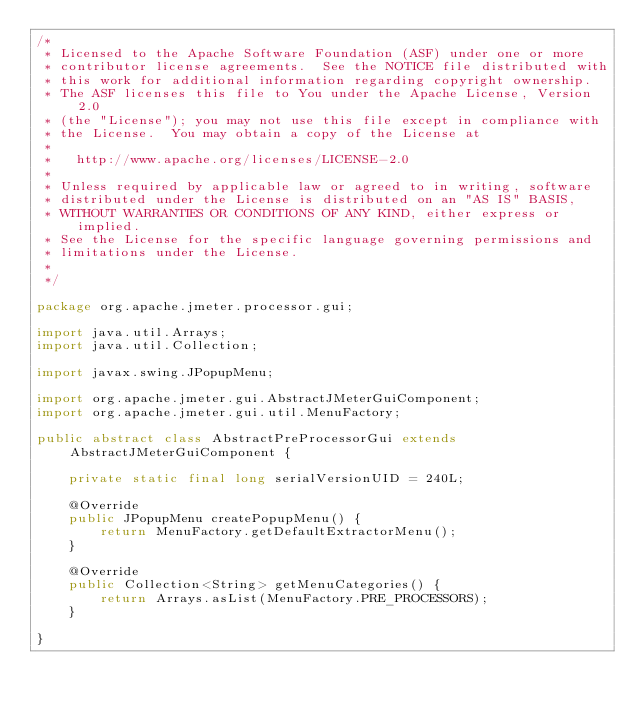Convert code to text. <code><loc_0><loc_0><loc_500><loc_500><_Java_>/*
 * Licensed to the Apache Software Foundation (ASF) under one or more
 * contributor license agreements.  See the NOTICE file distributed with
 * this work for additional information regarding copyright ownership.
 * The ASF licenses this file to You under the Apache License, Version 2.0
 * (the "License"); you may not use this file except in compliance with
 * the License.  You may obtain a copy of the License at
 *
 *   http://www.apache.org/licenses/LICENSE-2.0
 *
 * Unless required by applicable law or agreed to in writing, software
 * distributed under the License is distributed on an "AS IS" BASIS,
 * WITHOUT WARRANTIES OR CONDITIONS OF ANY KIND, either express or implied.
 * See the License for the specific language governing permissions and
 * limitations under the License.
 *
 */

package org.apache.jmeter.processor.gui;

import java.util.Arrays;
import java.util.Collection;

import javax.swing.JPopupMenu;

import org.apache.jmeter.gui.AbstractJMeterGuiComponent;
import org.apache.jmeter.gui.util.MenuFactory;

public abstract class AbstractPreProcessorGui extends AbstractJMeterGuiComponent {

    private static final long serialVersionUID = 240L;

    @Override
    public JPopupMenu createPopupMenu() {
        return MenuFactory.getDefaultExtractorMenu();
    }

    @Override
    public Collection<String> getMenuCategories() {
        return Arrays.asList(MenuFactory.PRE_PROCESSORS);
    }

}
</code> 